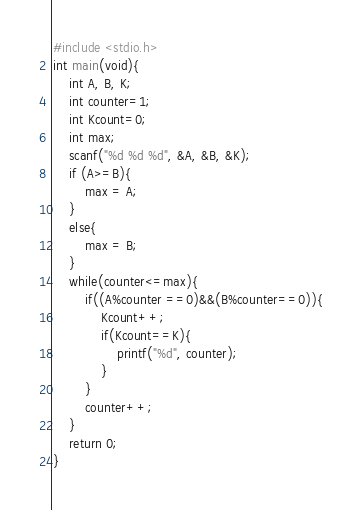<code> <loc_0><loc_0><loc_500><loc_500><_C_>#include <stdio.h>
int main(void){
    int A, B, K;
    int counter=1;
    int Kcount=0;
    int max;
    scanf("%d %d %d", &A, &B, &K);
    if (A>=B){
        max = A;
    }
    else{
        max = B;
    }
    while(counter<=max){
        if((A%counter ==0)&&(B%counter==0)){
            Kcount++;
            if(Kcount==K){
                printf("%d", counter);
            }
        }
        counter++;
    }
    return 0;
}</code> 